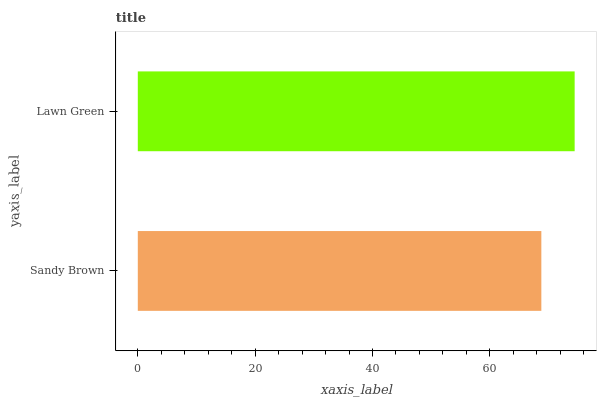Is Sandy Brown the minimum?
Answer yes or no. Yes. Is Lawn Green the maximum?
Answer yes or no. Yes. Is Lawn Green the minimum?
Answer yes or no. No. Is Lawn Green greater than Sandy Brown?
Answer yes or no. Yes. Is Sandy Brown less than Lawn Green?
Answer yes or no. Yes. Is Sandy Brown greater than Lawn Green?
Answer yes or no. No. Is Lawn Green less than Sandy Brown?
Answer yes or no. No. Is Lawn Green the high median?
Answer yes or no. Yes. Is Sandy Brown the low median?
Answer yes or no. Yes. Is Sandy Brown the high median?
Answer yes or no. No. Is Lawn Green the low median?
Answer yes or no. No. 